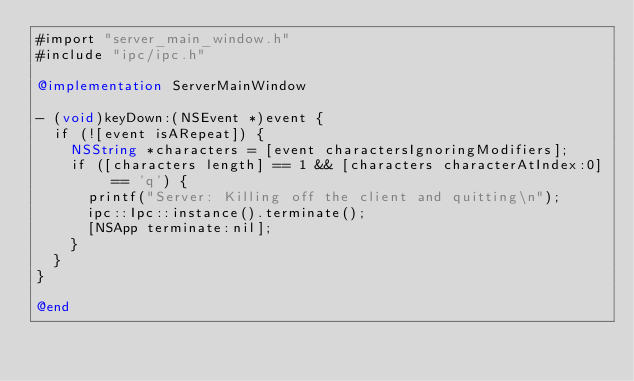<code> <loc_0><loc_0><loc_500><loc_500><_ObjectiveC_>#import "server_main_window.h"
#include "ipc/ipc.h"

@implementation ServerMainWindow

- (void)keyDown:(NSEvent *)event {
  if (![event isARepeat]) {
    NSString *characters = [event charactersIgnoringModifiers];
    if ([characters length] == 1 && [characters characterAtIndex:0] == 'q') {
      printf("Server: Killing off the client and quitting\n");
      ipc::Ipc::instance().terminate();
      [NSApp terminate:nil];
    }
  }
}

@end
</code> 